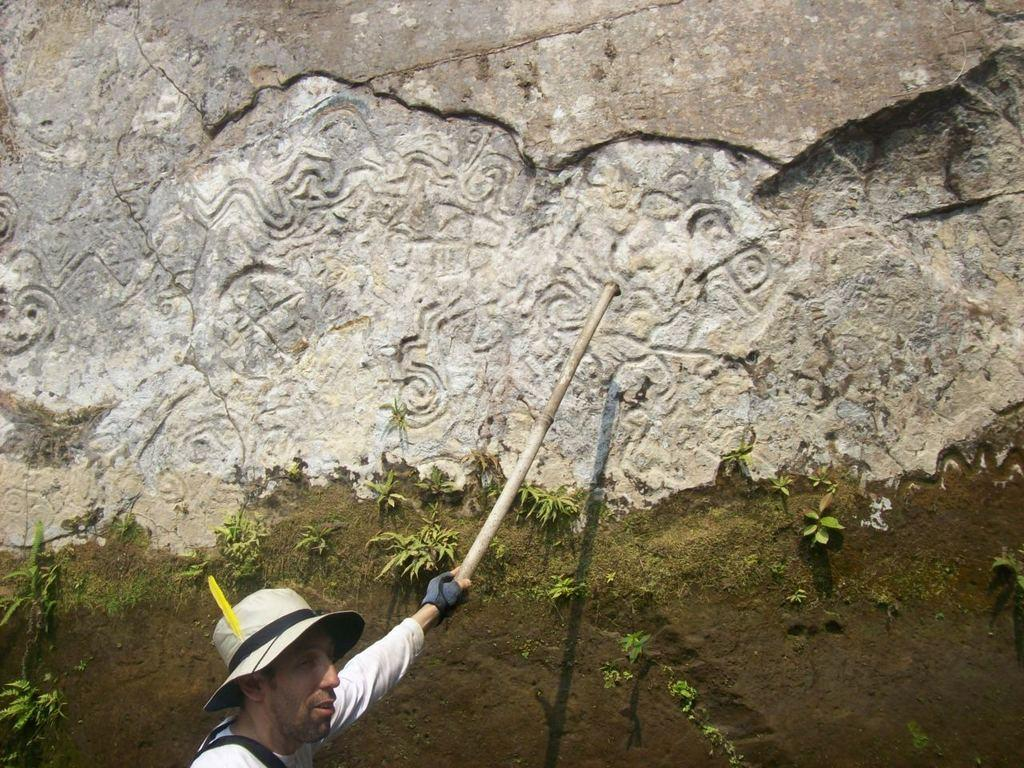Who or what is present in the image? There is a person in the image. What is the person wearing on their head? The person is wearing a hat. What is the person holding in their hand? The person is holding an object in their hand. What can be seen in the background of the image? There is a huge carved rock in the background of the image. What is on top of the carved rock? There is grass on the carved rock. What type of lace can be seen on the person's clothing in the image? There is no lace visible on the person's clothing in the image. What type of order is the person following in the image? There is no indication of the person following any specific order in the image. 